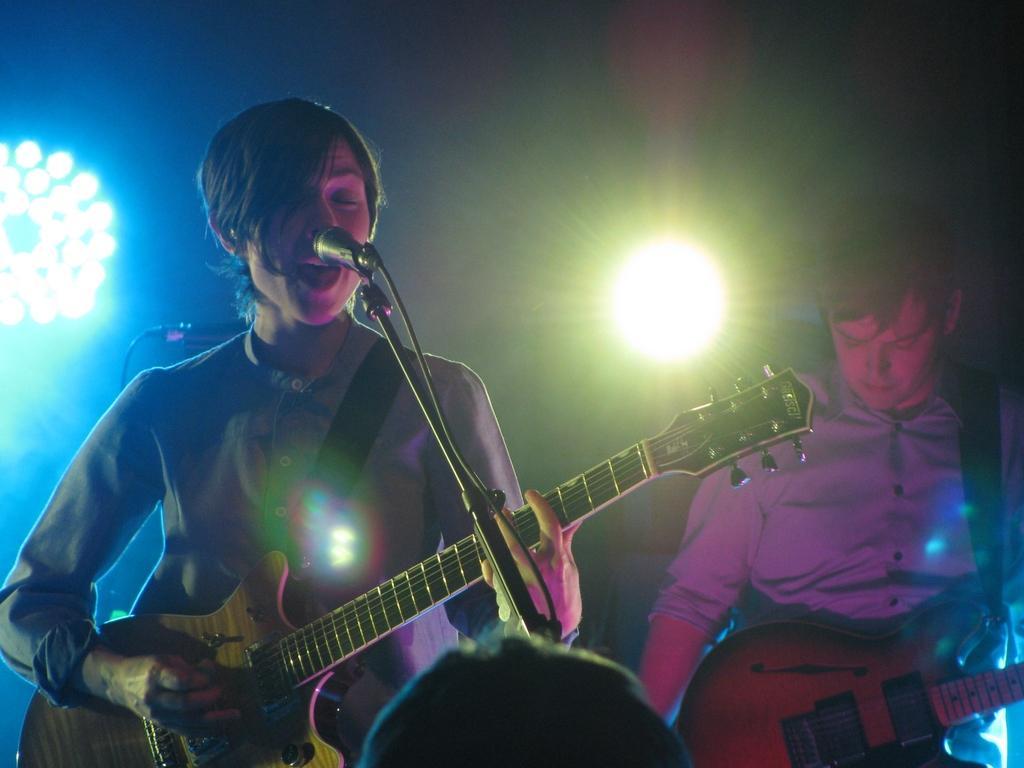Describe this image in one or two sentences. In this picture a woman is singing and playing guitar in front of microphone, and a man is playing guitar, in the background we can find couple of lights. 